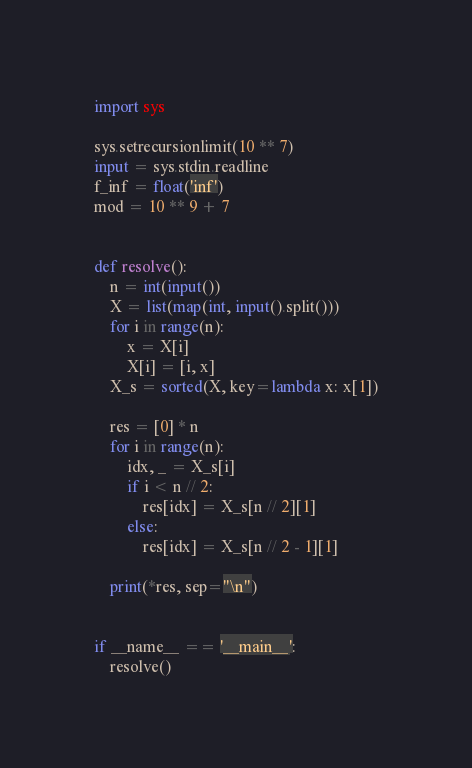<code> <loc_0><loc_0><loc_500><loc_500><_Python_>import sys

sys.setrecursionlimit(10 ** 7)
input = sys.stdin.readline
f_inf = float('inf')
mod = 10 ** 9 + 7


def resolve():
    n = int(input())
    X = list(map(int, input().split()))
    for i in range(n):
        x = X[i]
        X[i] = [i, x]
    X_s = sorted(X, key=lambda x: x[1])

    res = [0] * n
    for i in range(n):
        idx, _ = X_s[i]
        if i < n // 2:
            res[idx] = X_s[n // 2][1]
        else:
            res[idx] = X_s[n // 2 - 1][1]

    print(*res, sep="\n")


if __name__ == '__main__':
    resolve()
</code> 